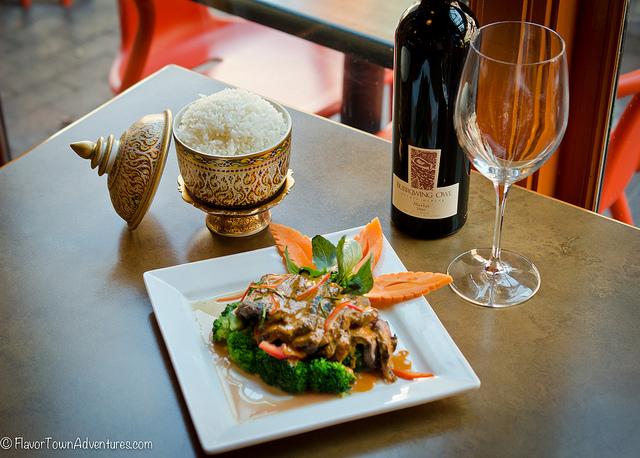Is the glass empty?
Keep it brief. Yes. What is in the golden bowl?
Short answer required. Rice. Is this a fast food restaurant?
Give a very brief answer. No. 